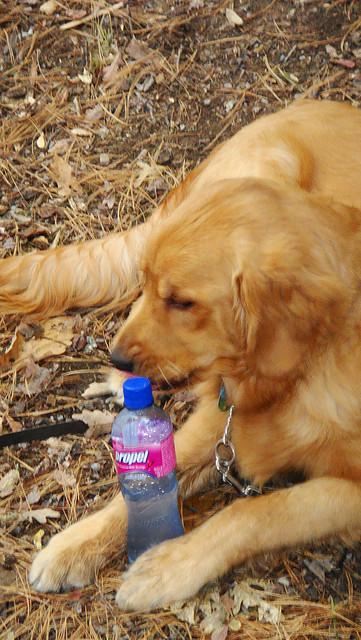Is the dog wearing a leash?
Be succinct. Yes. What is the dog holding in his paws?
Short answer required. Water bottle. What color is the dog?
Keep it brief. Tan. Is the dog drinking a bottle of water?
Answer briefly. No. What kind of animal is this?
Be succinct. Dog. 